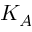<formula> <loc_0><loc_0><loc_500><loc_500>K _ { A }</formula> 